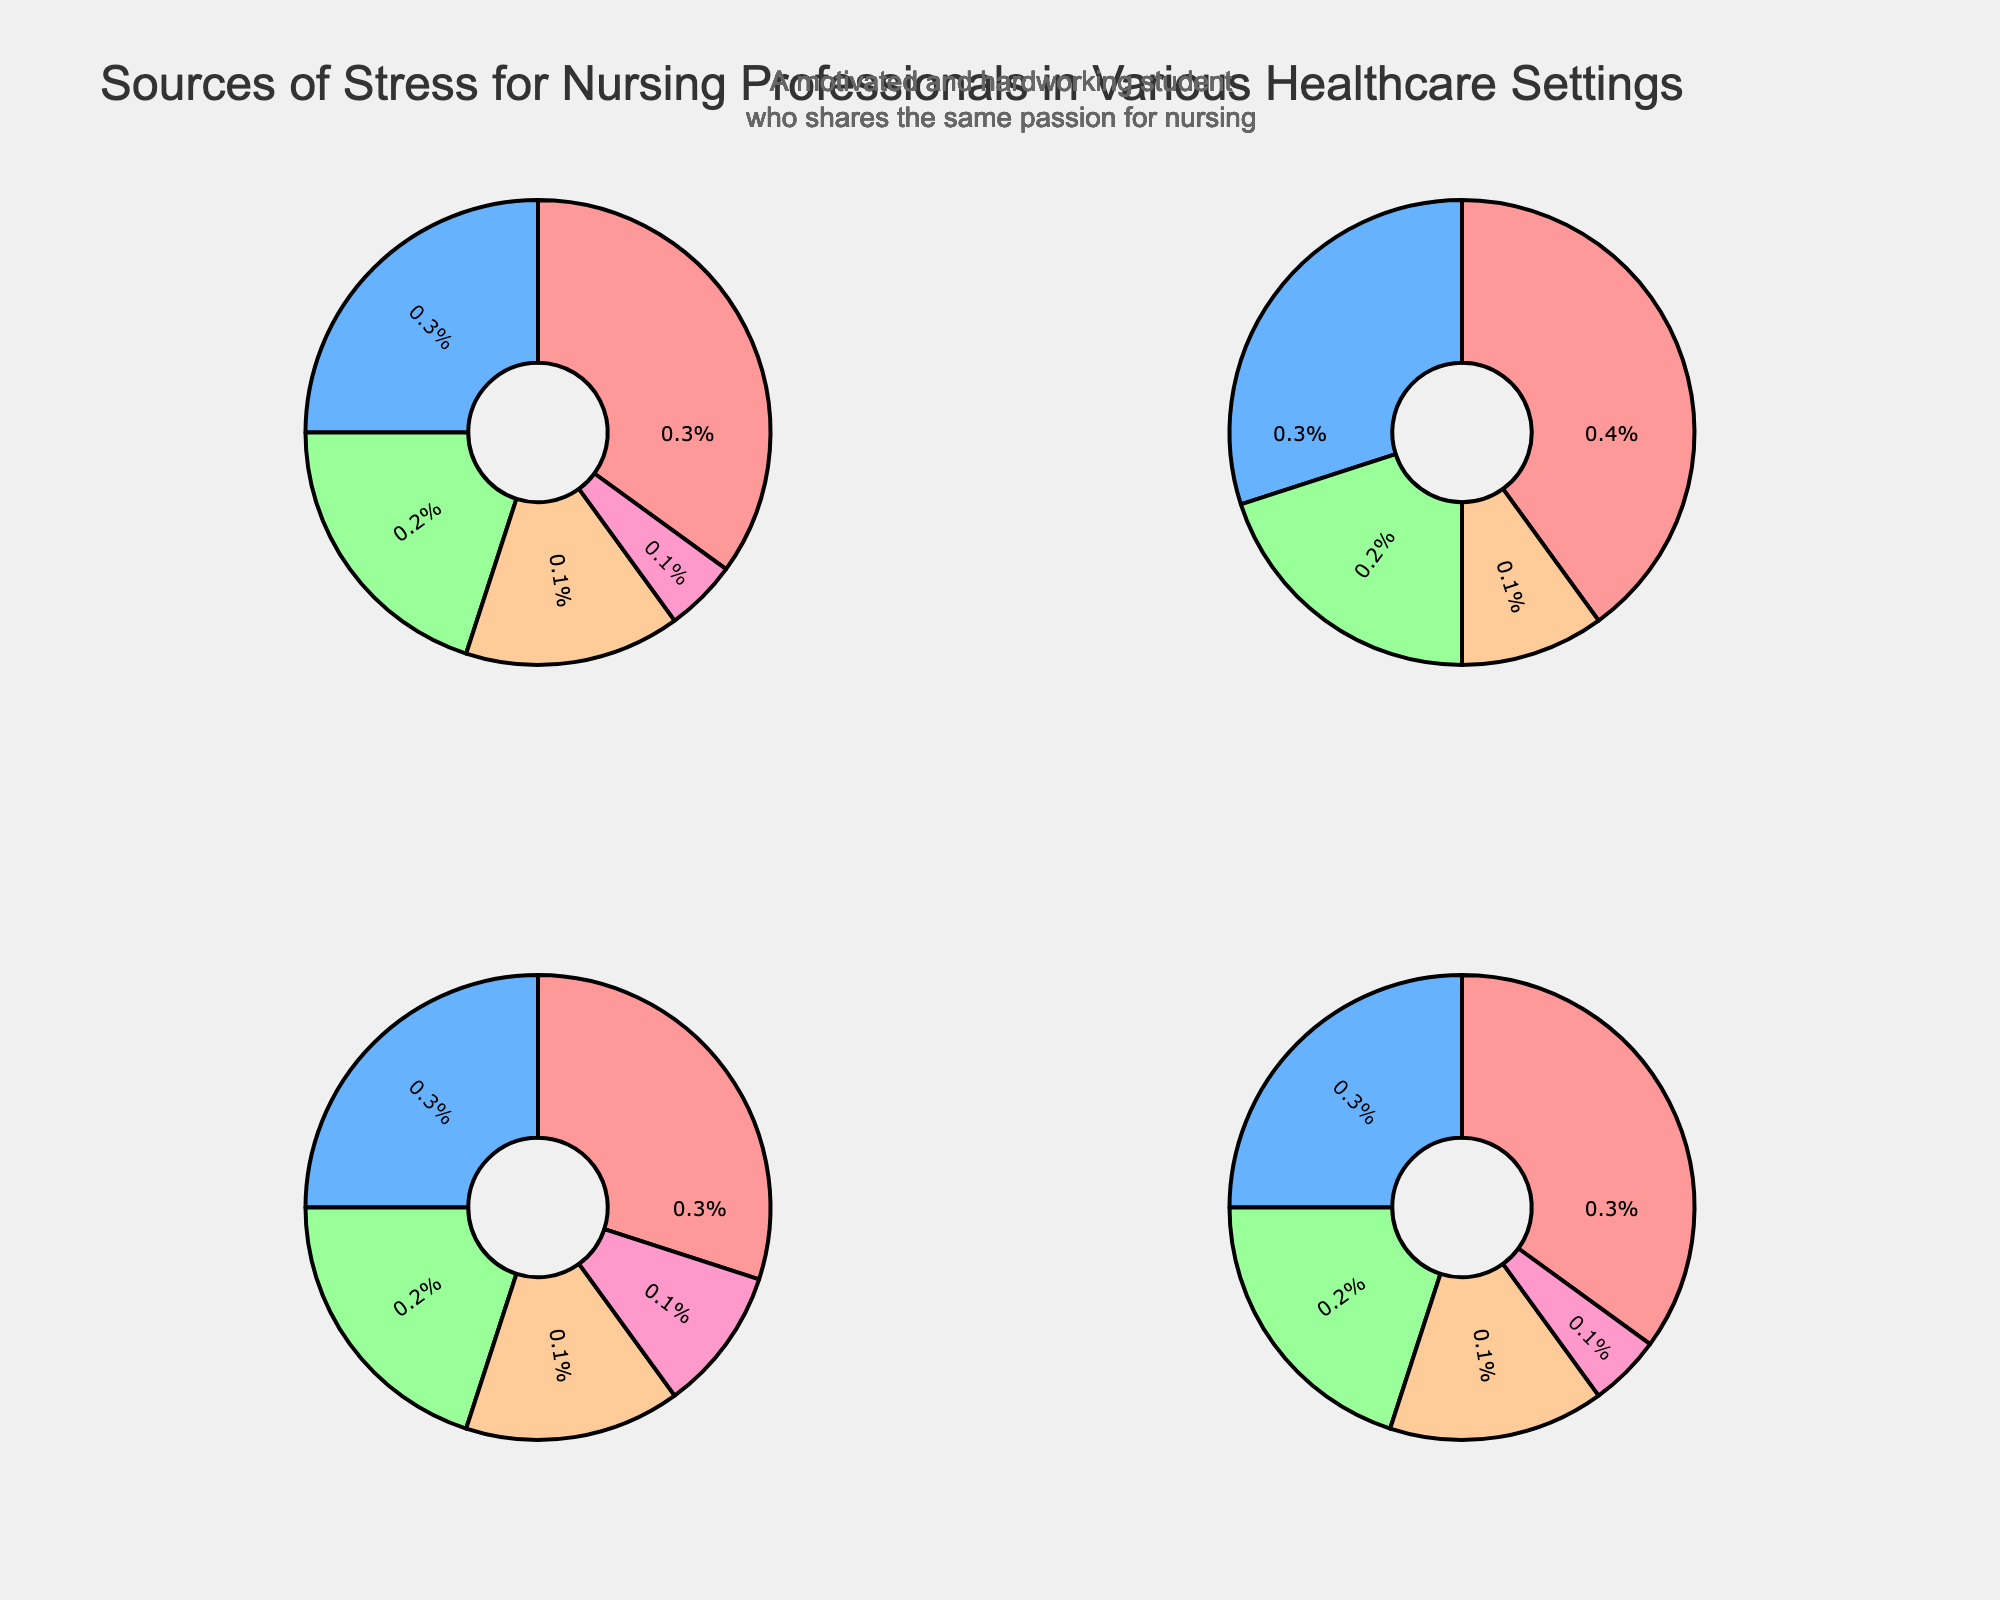What is the most common source of stress for nursing professionals in a hospital setting? The pie chart for the hospital setting shows that "Heavy workload" has the largest slice, representing 35% of the total sources of stress.
Answer: Heavy workload Which setting has "Understaffing" as a significant source of stress? By looking at the four pie charts, "Understaffing" appears in the Nursing Home setting chart, where it constitutes 25% of the stress sources.
Answer: Nursing Home What percentage of stress in the Community Health setting is attributed to "Cultural barriers"? In the pie chart for the Community Health setting, "Cultural barriers" is shown to account for 20% of the total stress sources.
Answer: 20% How do "Emotional demands" and "Long working hours" compare as stress sources in a hospital setting? The pie chart for the hospital setting shows "Emotional demands" at 25% and "Long working hours" at 20%. Comparing these, "Emotional demands" is a larger source of stress than "Long working hours".
Answer: Emotional demands is greater Which stress source in the Emergency Room setting accounts for the highest percentage? The pie chart for the Emergency Room setting clearly shows that "Time pressure" accounts for the highest percentage at 40%.
Answer: Time pressure In the Nursing Home setting, is the combined percentage of "Patient behavioral issues" and "Physical demands" greater than or less than 50%? In the Nursing Home setting, "Patient behavioral issues" is 30% and "Physical demands" is 20%. Combining these gives 30% + 20% = 50%.
Answer: Equal to 50% What is the least common source of stress in the Community Health setting? The pie chart for the Community Health setting indicates that "Isolation" is the least common source of stress, accounting for only 5%.
Answer: Isolation Across all settings, which specific source of stress is mentioned both in the Emergency Room and Nursing Home settings? By examining the pie charts for the Emergency Room and Nursing Home settings, "Shift work" is not listed. Comparing keywords only shows relevant, non-matching details. No common sources like "Patient behavioral issues" or others are present in both settings by name.
Answer: None How does the percentage of "Limited resources" in Community Health compare to "Heavy workload" in a hospital setting? In Community Health, "Limited resources" is 35%, while in a hospital setting, "Heavy workload" is also 35%. Therefore, they are equal.
Answer: Equal What is the combined percentage for "Time pressure" and "Critical patient care" in the Emergency Room setting? The pie chart for the Emergency Room setting shows "Time pressure" at 40% and "Critical patient care" at 30%. The combined percentage is 40% + 30% = 70%.
Answer: 70% 